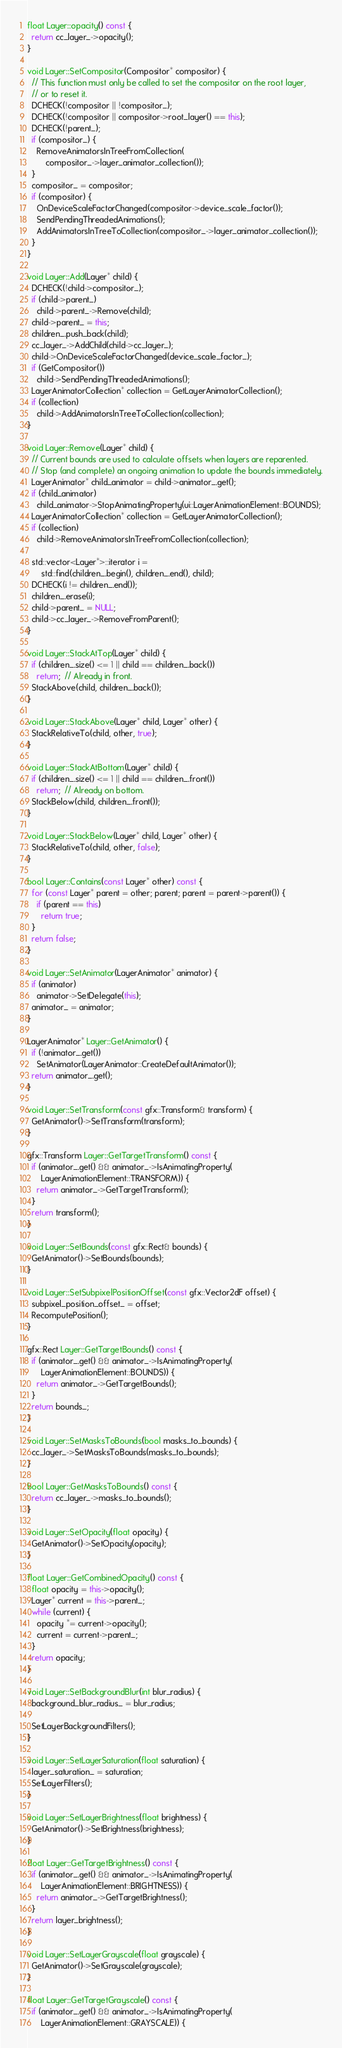Convert code to text. <code><loc_0><loc_0><loc_500><loc_500><_C++_>float Layer::opacity() const {
  return cc_layer_->opacity();
}

void Layer::SetCompositor(Compositor* compositor) {
  // This function must only be called to set the compositor on the root layer,
  // or to reset it.
  DCHECK(!compositor || !compositor_);
  DCHECK(!compositor || compositor->root_layer() == this);
  DCHECK(!parent_);
  if (compositor_) {
    RemoveAnimatorsInTreeFromCollection(
        compositor_->layer_animator_collection());
  }
  compositor_ = compositor;
  if (compositor) {
    OnDeviceScaleFactorChanged(compositor->device_scale_factor());
    SendPendingThreadedAnimations();
    AddAnimatorsInTreeToCollection(compositor_->layer_animator_collection());
  }
}

void Layer::Add(Layer* child) {
  DCHECK(!child->compositor_);
  if (child->parent_)
    child->parent_->Remove(child);
  child->parent_ = this;
  children_.push_back(child);
  cc_layer_->AddChild(child->cc_layer_);
  child->OnDeviceScaleFactorChanged(device_scale_factor_);
  if (GetCompositor())
    child->SendPendingThreadedAnimations();
  LayerAnimatorCollection* collection = GetLayerAnimatorCollection();
  if (collection)
    child->AddAnimatorsInTreeToCollection(collection);
}

void Layer::Remove(Layer* child) {
  // Current bounds are used to calculate offsets when layers are reparented.
  // Stop (and complete) an ongoing animation to update the bounds immediately.
  LayerAnimator* child_animator = child->animator_.get();
  if (child_animator)
    child_animator->StopAnimatingProperty(ui::LayerAnimationElement::BOUNDS);
  LayerAnimatorCollection* collection = GetLayerAnimatorCollection();
  if (collection)
    child->RemoveAnimatorsInTreeFromCollection(collection);

  std::vector<Layer*>::iterator i =
      std::find(children_.begin(), children_.end(), child);
  DCHECK(i != children_.end());
  children_.erase(i);
  child->parent_ = NULL;
  child->cc_layer_->RemoveFromParent();
}

void Layer::StackAtTop(Layer* child) {
  if (children_.size() <= 1 || child == children_.back())
    return;  // Already in front.
  StackAbove(child, children_.back());
}

void Layer::StackAbove(Layer* child, Layer* other) {
  StackRelativeTo(child, other, true);
}

void Layer::StackAtBottom(Layer* child) {
  if (children_.size() <= 1 || child == children_.front())
    return;  // Already on bottom.
  StackBelow(child, children_.front());
}

void Layer::StackBelow(Layer* child, Layer* other) {
  StackRelativeTo(child, other, false);
}

bool Layer::Contains(const Layer* other) const {
  for (const Layer* parent = other; parent; parent = parent->parent()) {
    if (parent == this)
      return true;
  }
  return false;
}

void Layer::SetAnimator(LayerAnimator* animator) {
  if (animator)
    animator->SetDelegate(this);
  animator_ = animator;
}

LayerAnimator* Layer::GetAnimator() {
  if (!animator_.get())
    SetAnimator(LayerAnimator::CreateDefaultAnimator());
  return animator_.get();
}

void Layer::SetTransform(const gfx::Transform& transform) {
  GetAnimator()->SetTransform(transform);
}

gfx::Transform Layer::GetTargetTransform() const {
  if (animator_.get() && animator_->IsAnimatingProperty(
      LayerAnimationElement::TRANSFORM)) {
    return animator_->GetTargetTransform();
  }
  return transform();
}

void Layer::SetBounds(const gfx::Rect& bounds) {
  GetAnimator()->SetBounds(bounds);
}

void Layer::SetSubpixelPositionOffset(const gfx::Vector2dF offset) {
  subpixel_position_offset_ = offset;
  RecomputePosition();
}

gfx::Rect Layer::GetTargetBounds() const {
  if (animator_.get() && animator_->IsAnimatingProperty(
      LayerAnimationElement::BOUNDS)) {
    return animator_->GetTargetBounds();
  }
  return bounds_;
}

void Layer::SetMasksToBounds(bool masks_to_bounds) {
  cc_layer_->SetMasksToBounds(masks_to_bounds);
}

bool Layer::GetMasksToBounds() const {
  return cc_layer_->masks_to_bounds();
}

void Layer::SetOpacity(float opacity) {
  GetAnimator()->SetOpacity(opacity);
}

float Layer::GetCombinedOpacity() const {
  float opacity = this->opacity();
  Layer* current = this->parent_;
  while (current) {
    opacity *= current->opacity();
    current = current->parent_;
  }
  return opacity;
}

void Layer::SetBackgroundBlur(int blur_radius) {
  background_blur_radius_ = blur_radius;

  SetLayerBackgroundFilters();
}

void Layer::SetLayerSaturation(float saturation) {
  layer_saturation_ = saturation;
  SetLayerFilters();
}

void Layer::SetLayerBrightness(float brightness) {
  GetAnimator()->SetBrightness(brightness);
}

float Layer::GetTargetBrightness() const {
  if (animator_.get() && animator_->IsAnimatingProperty(
      LayerAnimationElement::BRIGHTNESS)) {
    return animator_->GetTargetBrightness();
  }
  return layer_brightness();
}

void Layer::SetLayerGrayscale(float grayscale) {
  GetAnimator()->SetGrayscale(grayscale);
}

float Layer::GetTargetGrayscale() const {
  if (animator_.get() && animator_->IsAnimatingProperty(
      LayerAnimationElement::GRAYSCALE)) {</code> 